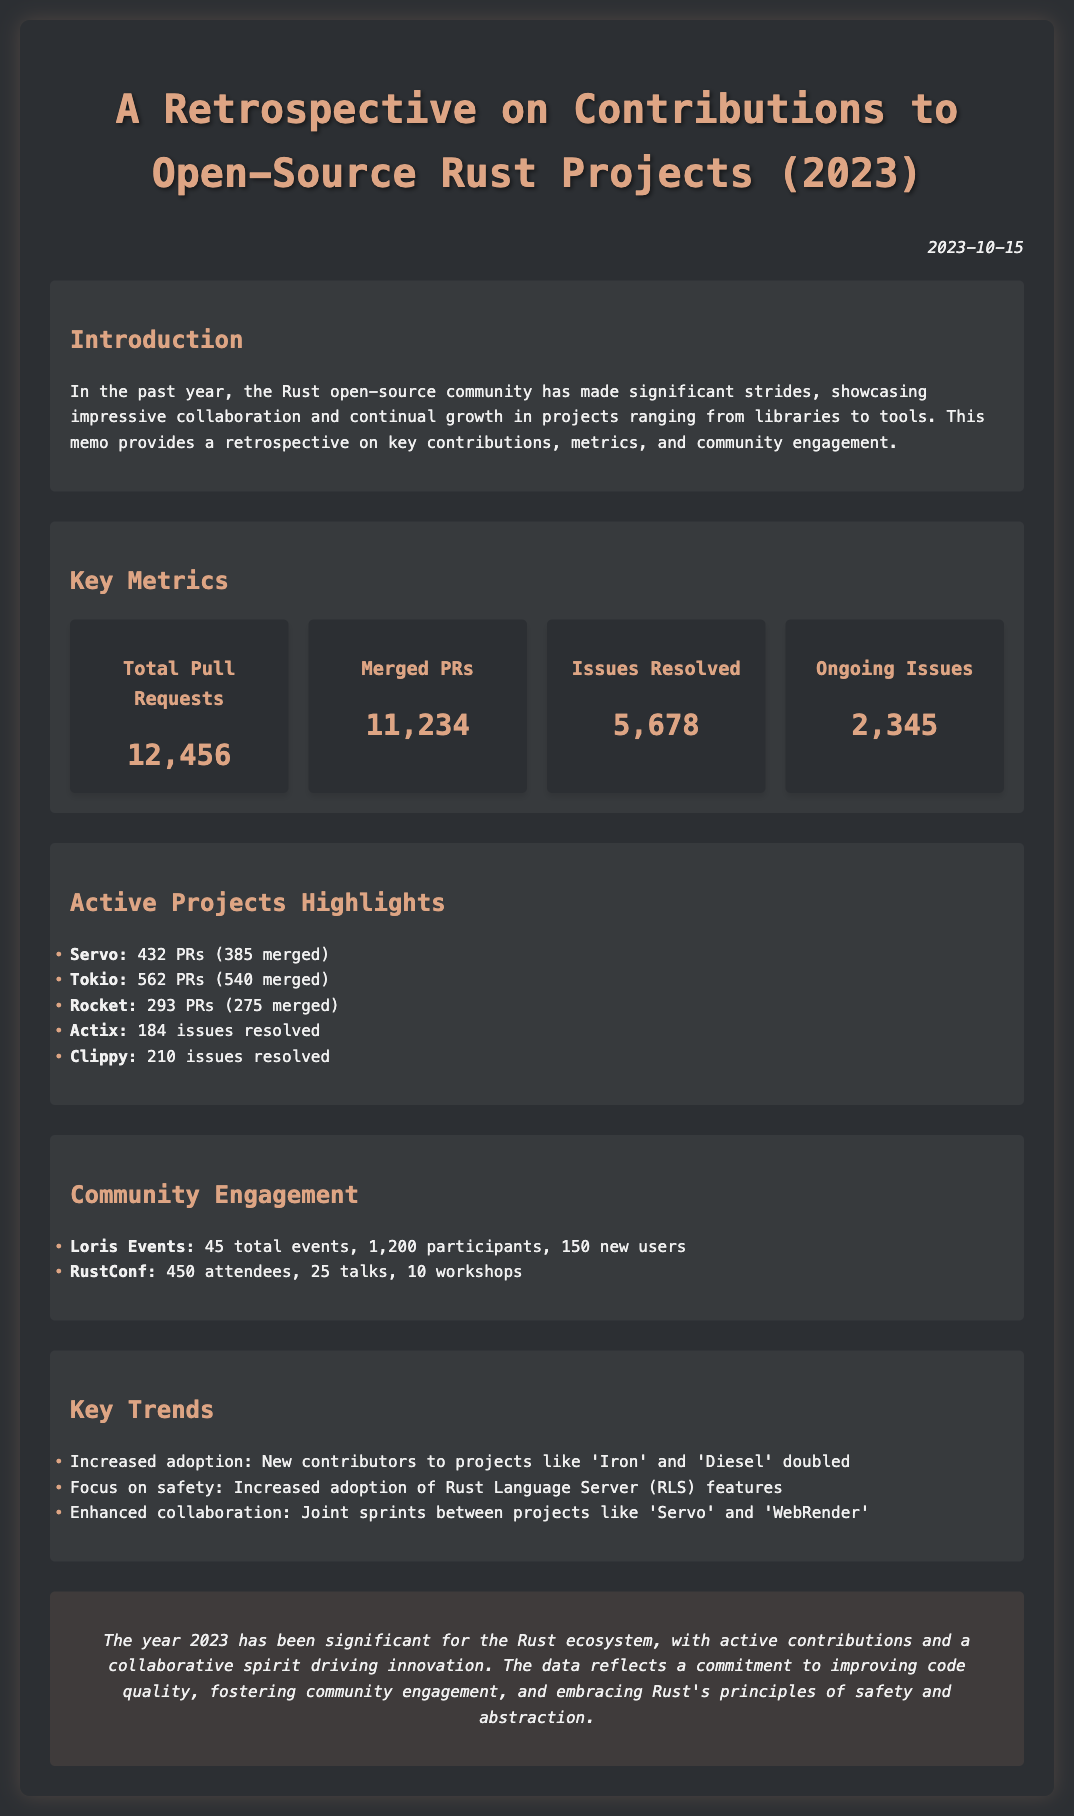what is the date of the memo? The date of the memo is provided right under the title, indicating when it was created.
Answer: 2023-10-15 how many total pull requests were made? The total pull requests can be found in the key metrics section of the document.
Answer: 12,456 how many PRs were merged? The number of merged PRs is specifically mentioned alongside the total pull requests in the metrics section.
Answer: 11,234 which project had the most PRs? The project with the most PRs is listed in the active projects highlights.
Answer: Tokio how many ongoing issues are there? The ongoing issues count is included in the key metrics section, providing insight into project maintenance.
Answer: 2,345 what was the attendance of RustConf? The attendance figure for RustConf is presented in the community engagement section.
Answer: 450 how many participants did Loris Events have? The total participants in Loris Events is found in the community engagement section of the memo.
Answer: 1,200 which projects had issues resolved? The projects with resolved issues are listed in the active projects highlights, showcasing community effort.
Answer: Actix, Clippy what does the conclusion emphasize? The conclusion summarizes the document's findings, highlighting key themes from the contributions this year.
Answer: Commitment to improving code quality, fostering community engagement, and embracing safety and abstraction 